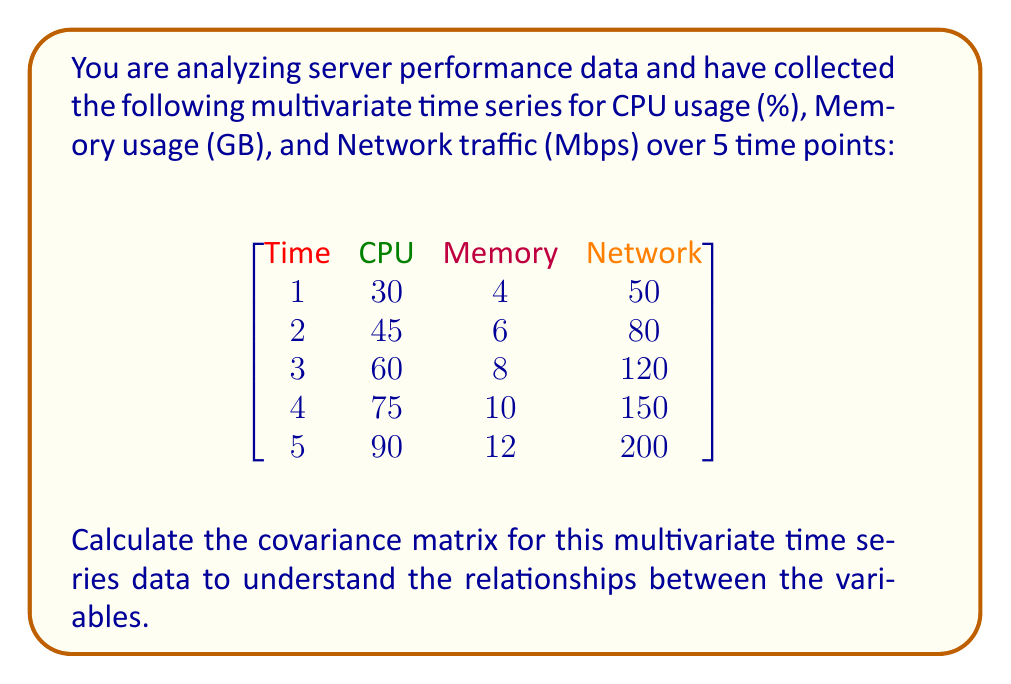Provide a solution to this math problem. To calculate the covariance matrix, we'll follow these steps:

1. Calculate the mean for each variable:
   $\bar{X}_{\text{CPU}} = \frac{30 + 45 + 60 + 75 + 90}{5} = 60$
   $\bar{X}_{\text{Memory}} = \frac{4 + 6 + 8 + 10 + 12}{5} = 8$
   $\bar{X}_{\text{Network}} = \frac{50 + 80 + 120 + 150 + 200}{5} = 120$

2. Calculate the deviations from the mean for each variable:
   CPU: [-30, -15, 0, 15, 30]
   Memory: [-4, -2, 0, 2, 4]
   Network: [-70, -40, 0, 30, 80]

3. Calculate the covariances:
   $\text{Cov}(X, Y) = \frac{1}{n-1} \sum_{i=1}^n (X_i - \bar{X})(Y_i - \bar{Y})$

   $\text{Cov}(\text{CPU}, \text{CPU}) = \frac{1}{4}((-30)^2 + (-15)^2 + 0^2 + 15^2 + 30^2) = 525$
   
   $\text{Cov}(\text{CPU}, \text{Memory}) = \frac{1}{4}((-30)(-4) + (-15)(-2) + 0(0) + 15(2) + 30(4)) = 70$
   
   $\text{Cov}(\text{CPU}, \text{Network}) = \frac{1}{4}((-30)(-70) + (-15)(-40) + 0(0) + 15(30) + 30(80)) = 1225$
   
   $\text{Cov}(\text{Memory}, \text{Memory}) = \frac{1}{4}((-4)^2 + (-2)^2 + 0^2 + 2^2 + 4^2) = 10$
   
   $\text{Cov}(\text{Memory}, \text{Network}) = \frac{1}{4}((-4)(-70) + (-2)(-40) + 0(0) + 2(30) + 4(80)) = 165$
   
   $\text{Cov}(\text{Network}, \text{Network}) = \frac{1}{4}((-70)^2 + (-40)^2 + 0^2 + 30^2 + 80^2) = 3675$

4. Construct the covariance matrix:
   $$
   \begin{bmatrix}
   525 & 70 & 1225 \\
   70 & 10 & 165 \\
   1225 & 165 & 3675
   \end{bmatrix}
   $$
Answer: $$
\begin{bmatrix}
525 & 70 & 1225 \\
70 & 10 & 165 \\
1225 & 165 & 3675
\end{bmatrix}
$$ 